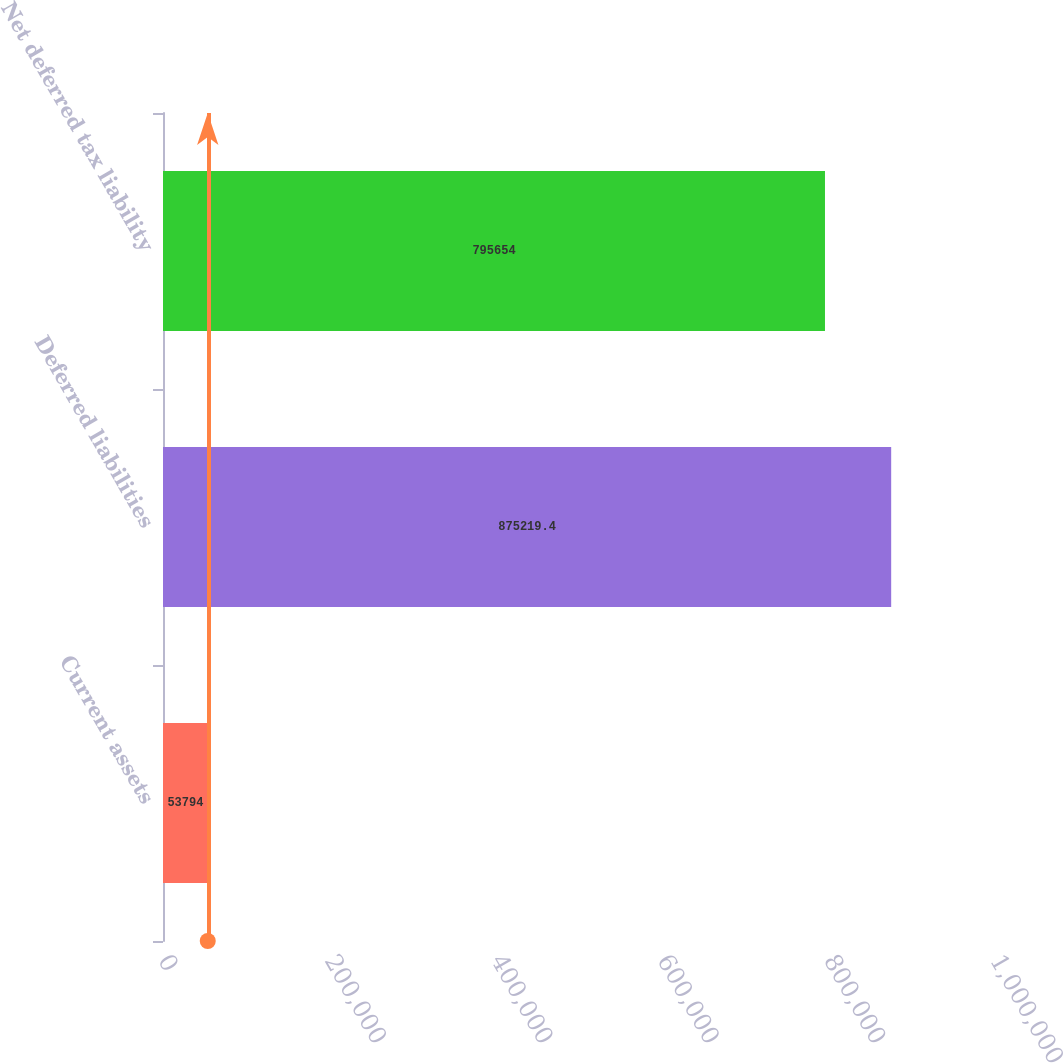Convert chart. <chart><loc_0><loc_0><loc_500><loc_500><bar_chart><fcel>Current assets<fcel>Deferred liabilities<fcel>Net deferred tax liability<nl><fcel>53794<fcel>875219<fcel>795654<nl></chart> 